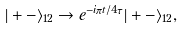<formula> <loc_0><loc_0><loc_500><loc_500>| + - \rangle _ { 1 2 } \rightarrow e ^ { - i \pi t / 4 \tau } | + - \rangle _ { 1 2 } ,</formula> 